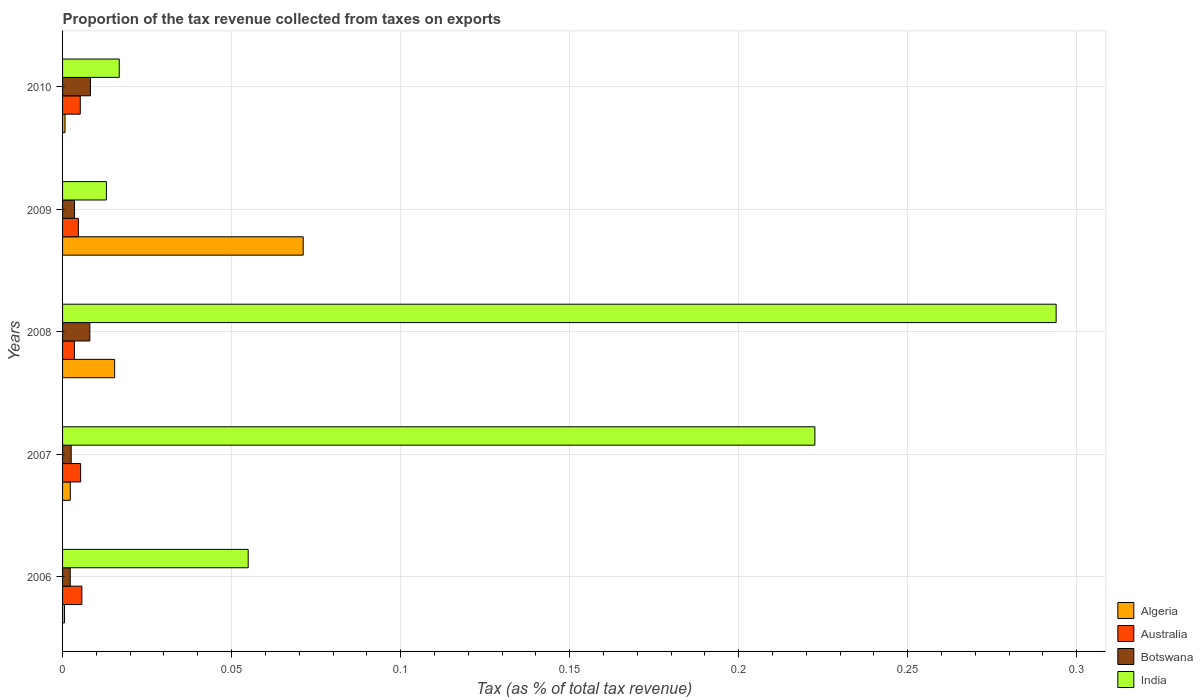How many different coloured bars are there?
Keep it short and to the point. 4. Are the number of bars per tick equal to the number of legend labels?
Provide a short and direct response. Yes. Are the number of bars on each tick of the Y-axis equal?
Your answer should be very brief. Yes. How many bars are there on the 1st tick from the bottom?
Make the answer very short. 4. What is the label of the 4th group of bars from the top?
Provide a short and direct response. 2007. In how many cases, is the number of bars for a given year not equal to the number of legend labels?
Offer a very short reply. 0. What is the proportion of the tax revenue collected in Australia in 2006?
Provide a short and direct response. 0.01. Across all years, what is the maximum proportion of the tax revenue collected in Botswana?
Your answer should be very brief. 0.01. Across all years, what is the minimum proportion of the tax revenue collected in India?
Keep it short and to the point. 0.01. In which year was the proportion of the tax revenue collected in Algeria minimum?
Make the answer very short. 2006. What is the total proportion of the tax revenue collected in India in the graph?
Ensure brevity in your answer.  0.6. What is the difference between the proportion of the tax revenue collected in Australia in 2007 and that in 2010?
Keep it short and to the point. 0. What is the difference between the proportion of the tax revenue collected in India in 2010 and the proportion of the tax revenue collected in Australia in 2008?
Make the answer very short. 0.01. What is the average proportion of the tax revenue collected in Australia per year?
Provide a succinct answer. 0. In the year 2010, what is the difference between the proportion of the tax revenue collected in Botswana and proportion of the tax revenue collected in Australia?
Keep it short and to the point. 0. What is the ratio of the proportion of the tax revenue collected in India in 2006 to that in 2010?
Your answer should be compact. 3.27. Is the difference between the proportion of the tax revenue collected in Botswana in 2007 and 2010 greater than the difference between the proportion of the tax revenue collected in Australia in 2007 and 2010?
Ensure brevity in your answer.  No. What is the difference between the highest and the second highest proportion of the tax revenue collected in Algeria?
Your answer should be very brief. 0.06. What is the difference between the highest and the lowest proportion of the tax revenue collected in Botswana?
Give a very brief answer. 0.01. Is the sum of the proportion of the tax revenue collected in Australia in 2006 and 2009 greater than the maximum proportion of the tax revenue collected in India across all years?
Give a very brief answer. No. What does the 4th bar from the top in 2008 represents?
Keep it short and to the point. Algeria. What does the 2nd bar from the bottom in 2007 represents?
Offer a very short reply. Australia. Is it the case that in every year, the sum of the proportion of the tax revenue collected in India and proportion of the tax revenue collected in Algeria is greater than the proportion of the tax revenue collected in Australia?
Offer a very short reply. Yes. How many legend labels are there?
Your response must be concise. 4. What is the title of the graph?
Your answer should be very brief. Proportion of the tax revenue collected from taxes on exports. Does "Dominica" appear as one of the legend labels in the graph?
Give a very brief answer. No. What is the label or title of the X-axis?
Offer a very short reply. Tax (as % of total tax revenue). What is the label or title of the Y-axis?
Offer a terse response. Years. What is the Tax (as % of total tax revenue) in Algeria in 2006?
Your answer should be very brief. 0. What is the Tax (as % of total tax revenue) of Australia in 2006?
Provide a succinct answer. 0.01. What is the Tax (as % of total tax revenue) of Botswana in 2006?
Make the answer very short. 0. What is the Tax (as % of total tax revenue) in India in 2006?
Give a very brief answer. 0.05. What is the Tax (as % of total tax revenue) of Algeria in 2007?
Provide a succinct answer. 0. What is the Tax (as % of total tax revenue) in Australia in 2007?
Make the answer very short. 0.01. What is the Tax (as % of total tax revenue) of Botswana in 2007?
Give a very brief answer. 0. What is the Tax (as % of total tax revenue) in India in 2007?
Make the answer very short. 0.22. What is the Tax (as % of total tax revenue) in Algeria in 2008?
Ensure brevity in your answer.  0.02. What is the Tax (as % of total tax revenue) of Australia in 2008?
Your answer should be compact. 0. What is the Tax (as % of total tax revenue) in Botswana in 2008?
Make the answer very short. 0.01. What is the Tax (as % of total tax revenue) in India in 2008?
Offer a terse response. 0.29. What is the Tax (as % of total tax revenue) in Algeria in 2009?
Offer a very short reply. 0.07. What is the Tax (as % of total tax revenue) in Australia in 2009?
Make the answer very short. 0. What is the Tax (as % of total tax revenue) in Botswana in 2009?
Give a very brief answer. 0. What is the Tax (as % of total tax revenue) in India in 2009?
Your answer should be very brief. 0.01. What is the Tax (as % of total tax revenue) in Algeria in 2010?
Keep it short and to the point. 0. What is the Tax (as % of total tax revenue) in Australia in 2010?
Offer a very short reply. 0.01. What is the Tax (as % of total tax revenue) of Botswana in 2010?
Your answer should be compact. 0.01. What is the Tax (as % of total tax revenue) of India in 2010?
Keep it short and to the point. 0.02. Across all years, what is the maximum Tax (as % of total tax revenue) of Algeria?
Your answer should be very brief. 0.07. Across all years, what is the maximum Tax (as % of total tax revenue) in Australia?
Ensure brevity in your answer.  0.01. Across all years, what is the maximum Tax (as % of total tax revenue) in Botswana?
Your response must be concise. 0.01. Across all years, what is the maximum Tax (as % of total tax revenue) of India?
Your answer should be compact. 0.29. Across all years, what is the minimum Tax (as % of total tax revenue) in Algeria?
Ensure brevity in your answer.  0. Across all years, what is the minimum Tax (as % of total tax revenue) of Australia?
Your response must be concise. 0. Across all years, what is the minimum Tax (as % of total tax revenue) of Botswana?
Ensure brevity in your answer.  0. Across all years, what is the minimum Tax (as % of total tax revenue) in India?
Your response must be concise. 0.01. What is the total Tax (as % of total tax revenue) of Algeria in the graph?
Offer a very short reply. 0.09. What is the total Tax (as % of total tax revenue) in Australia in the graph?
Provide a succinct answer. 0.02. What is the total Tax (as % of total tax revenue) in Botswana in the graph?
Provide a short and direct response. 0.02. What is the total Tax (as % of total tax revenue) of India in the graph?
Make the answer very short. 0.6. What is the difference between the Tax (as % of total tax revenue) of Algeria in 2006 and that in 2007?
Provide a short and direct response. -0. What is the difference between the Tax (as % of total tax revenue) of Botswana in 2006 and that in 2007?
Ensure brevity in your answer.  -0. What is the difference between the Tax (as % of total tax revenue) of India in 2006 and that in 2007?
Your answer should be very brief. -0.17. What is the difference between the Tax (as % of total tax revenue) of Algeria in 2006 and that in 2008?
Give a very brief answer. -0.01. What is the difference between the Tax (as % of total tax revenue) in Australia in 2006 and that in 2008?
Provide a succinct answer. 0. What is the difference between the Tax (as % of total tax revenue) of Botswana in 2006 and that in 2008?
Ensure brevity in your answer.  -0.01. What is the difference between the Tax (as % of total tax revenue) of India in 2006 and that in 2008?
Make the answer very short. -0.24. What is the difference between the Tax (as % of total tax revenue) in Algeria in 2006 and that in 2009?
Give a very brief answer. -0.07. What is the difference between the Tax (as % of total tax revenue) in Botswana in 2006 and that in 2009?
Your answer should be compact. -0. What is the difference between the Tax (as % of total tax revenue) of India in 2006 and that in 2009?
Your answer should be compact. 0.04. What is the difference between the Tax (as % of total tax revenue) of Algeria in 2006 and that in 2010?
Your answer should be compact. -0. What is the difference between the Tax (as % of total tax revenue) in Botswana in 2006 and that in 2010?
Make the answer very short. -0.01. What is the difference between the Tax (as % of total tax revenue) in India in 2006 and that in 2010?
Give a very brief answer. 0.04. What is the difference between the Tax (as % of total tax revenue) of Algeria in 2007 and that in 2008?
Your answer should be compact. -0.01. What is the difference between the Tax (as % of total tax revenue) of Australia in 2007 and that in 2008?
Your response must be concise. 0. What is the difference between the Tax (as % of total tax revenue) of Botswana in 2007 and that in 2008?
Give a very brief answer. -0.01. What is the difference between the Tax (as % of total tax revenue) in India in 2007 and that in 2008?
Keep it short and to the point. -0.07. What is the difference between the Tax (as % of total tax revenue) in Algeria in 2007 and that in 2009?
Offer a very short reply. -0.07. What is the difference between the Tax (as % of total tax revenue) of Australia in 2007 and that in 2009?
Your answer should be very brief. 0. What is the difference between the Tax (as % of total tax revenue) of Botswana in 2007 and that in 2009?
Provide a short and direct response. -0. What is the difference between the Tax (as % of total tax revenue) of India in 2007 and that in 2009?
Offer a very short reply. 0.21. What is the difference between the Tax (as % of total tax revenue) of Algeria in 2007 and that in 2010?
Your answer should be compact. 0. What is the difference between the Tax (as % of total tax revenue) in Botswana in 2007 and that in 2010?
Your answer should be very brief. -0.01. What is the difference between the Tax (as % of total tax revenue) in India in 2007 and that in 2010?
Your answer should be very brief. 0.21. What is the difference between the Tax (as % of total tax revenue) of Algeria in 2008 and that in 2009?
Keep it short and to the point. -0.06. What is the difference between the Tax (as % of total tax revenue) of Australia in 2008 and that in 2009?
Your answer should be compact. -0. What is the difference between the Tax (as % of total tax revenue) in Botswana in 2008 and that in 2009?
Offer a terse response. 0. What is the difference between the Tax (as % of total tax revenue) in India in 2008 and that in 2009?
Ensure brevity in your answer.  0.28. What is the difference between the Tax (as % of total tax revenue) in Algeria in 2008 and that in 2010?
Your answer should be very brief. 0.01. What is the difference between the Tax (as % of total tax revenue) in Australia in 2008 and that in 2010?
Keep it short and to the point. -0. What is the difference between the Tax (as % of total tax revenue) in Botswana in 2008 and that in 2010?
Provide a succinct answer. -0. What is the difference between the Tax (as % of total tax revenue) in India in 2008 and that in 2010?
Provide a short and direct response. 0.28. What is the difference between the Tax (as % of total tax revenue) of Algeria in 2009 and that in 2010?
Keep it short and to the point. 0.07. What is the difference between the Tax (as % of total tax revenue) in Australia in 2009 and that in 2010?
Your answer should be compact. -0. What is the difference between the Tax (as % of total tax revenue) of Botswana in 2009 and that in 2010?
Offer a terse response. -0. What is the difference between the Tax (as % of total tax revenue) of India in 2009 and that in 2010?
Your answer should be very brief. -0. What is the difference between the Tax (as % of total tax revenue) of Algeria in 2006 and the Tax (as % of total tax revenue) of Australia in 2007?
Your answer should be very brief. -0. What is the difference between the Tax (as % of total tax revenue) in Algeria in 2006 and the Tax (as % of total tax revenue) in Botswana in 2007?
Your response must be concise. -0. What is the difference between the Tax (as % of total tax revenue) of Algeria in 2006 and the Tax (as % of total tax revenue) of India in 2007?
Give a very brief answer. -0.22. What is the difference between the Tax (as % of total tax revenue) of Australia in 2006 and the Tax (as % of total tax revenue) of Botswana in 2007?
Your response must be concise. 0. What is the difference between the Tax (as % of total tax revenue) in Australia in 2006 and the Tax (as % of total tax revenue) in India in 2007?
Keep it short and to the point. -0.22. What is the difference between the Tax (as % of total tax revenue) in Botswana in 2006 and the Tax (as % of total tax revenue) in India in 2007?
Provide a short and direct response. -0.22. What is the difference between the Tax (as % of total tax revenue) in Algeria in 2006 and the Tax (as % of total tax revenue) in Australia in 2008?
Provide a short and direct response. -0. What is the difference between the Tax (as % of total tax revenue) in Algeria in 2006 and the Tax (as % of total tax revenue) in Botswana in 2008?
Your answer should be very brief. -0.01. What is the difference between the Tax (as % of total tax revenue) in Algeria in 2006 and the Tax (as % of total tax revenue) in India in 2008?
Keep it short and to the point. -0.29. What is the difference between the Tax (as % of total tax revenue) of Australia in 2006 and the Tax (as % of total tax revenue) of Botswana in 2008?
Provide a succinct answer. -0. What is the difference between the Tax (as % of total tax revenue) of Australia in 2006 and the Tax (as % of total tax revenue) of India in 2008?
Offer a very short reply. -0.29. What is the difference between the Tax (as % of total tax revenue) of Botswana in 2006 and the Tax (as % of total tax revenue) of India in 2008?
Keep it short and to the point. -0.29. What is the difference between the Tax (as % of total tax revenue) in Algeria in 2006 and the Tax (as % of total tax revenue) in Australia in 2009?
Offer a very short reply. -0. What is the difference between the Tax (as % of total tax revenue) in Algeria in 2006 and the Tax (as % of total tax revenue) in Botswana in 2009?
Ensure brevity in your answer.  -0. What is the difference between the Tax (as % of total tax revenue) in Algeria in 2006 and the Tax (as % of total tax revenue) in India in 2009?
Give a very brief answer. -0.01. What is the difference between the Tax (as % of total tax revenue) in Australia in 2006 and the Tax (as % of total tax revenue) in Botswana in 2009?
Your answer should be very brief. 0. What is the difference between the Tax (as % of total tax revenue) of Australia in 2006 and the Tax (as % of total tax revenue) of India in 2009?
Ensure brevity in your answer.  -0.01. What is the difference between the Tax (as % of total tax revenue) of Botswana in 2006 and the Tax (as % of total tax revenue) of India in 2009?
Keep it short and to the point. -0.01. What is the difference between the Tax (as % of total tax revenue) in Algeria in 2006 and the Tax (as % of total tax revenue) in Australia in 2010?
Your answer should be compact. -0. What is the difference between the Tax (as % of total tax revenue) of Algeria in 2006 and the Tax (as % of total tax revenue) of Botswana in 2010?
Your response must be concise. -0.01. What is the difference between the Tax (as % of total tax revenue) in Algeria in 2006 and the Tax (as % of total tax revenue) in India in 2010?
Provide a short and direct response. -0.02. What is the difference between the Tax (as % of total tax revenue) of Australia in 2006 and the Tax (as % of total tax revenue) of Botswana in 2010?
Offer a very short reply. -0. What is the difference between the Tax (as % of total tax revenue) in Australia in 2006 and the Tax (as % of total tax revenue) in India in 2010?
Ensure brevity in your answer.  -0.01. What is the difference between the Tax (as % of total tax revenue) of Botswana in 2006 and the Tax (as % of total tax revenue) of India in 2010?
Provide a succinct answer. -0.01. What is the difference between the Tax (as % of total tax revenue) in Algeria in 2007 and the Tax (as % of total tax revenue) in Australia in 2008?
Ensure brevity in your answer.  -0. What is the difference between the Tax (as % of total tax revenue) of Algeria in 2007 and the Tax (as % of total tax revenue) of Botswana in 2008?
Ensure brevity in your answer.  -0.01. What is the difference between the Tax (as % of total tax revenue) of Algeria in 2007 and the Tax (as % of total tax revenue) of India in 2008?
Your answer should be compact. -0.29. What is the difference between the Tax (as % of total tax revenue) in Australia in 2007 and the Tax (as % of total tax revenue) in Botswana in 2008?
Provide a short and direct response. -0. What is the difference between the Tax (as % of total tax revenue) of Australia in 2007 and the Tax (as % of total tax revenue) of India in 2008?
Offer a terse response. -0.29. What is the difference between the Tax (as % of total tax revenue) of Botswana in 2007 and the Tax (as % of total tax revenue) of India in 2008?
Your answer should be compact. -0.29. What is the difference between the Tax (as % of total tax revenue) in Algeria in 2007 and the Tax (as % of total tax revenue) in Australia in 2009?
Your response must be concise. -0. What is the difference between the Tax (as % of total tax revenue) in Algeria in 2007 and the Tax (as % of total tax revenue) in Botswana in 2009?
Ensure brevity in your answer.  -0. What is the difference between the Tax (as % of total tax revenue) of Algeria in 2007 and the Tax (as % of total tax revenue) of India in 2009?
Provide a succinct answer. -0.01. What is the difference between the Tax (as % of total tax revenue) of Australia in 2007 and the Tax (as % of total tax revenue) of Botswana in 2009?
Your answer should be compact. 0. What is the difference between the Tax (as % of total tax revenue) of Australia in 2007 and the Tax (as % of total tax revenue) of India in 2009?
Your answer should be very brief. -0.01. What is the difference between the Tax (as % of total tax revenue) of Botswana in 2007 and the Tax (as % of total tax revenue) of India in 2009?
Provide a succinct answer. -0.01. What is the difference between the Tax (as % of total tax revenue) in Algeria in 2007 and the Tax (as % of total tax revenue) in Australia in 2010?
Ensure brevity in your answer.  -0. What is the difference between the Tax (as % of total tax revenue) of Algeria in 2007 and the Tax (as % of total tax revenue) of Botswana in 2010?
Your answer should be compact. -0.01. What is the difference between the Tax (as % of total tax revenue) of Algeria in 2007 and the Tax (as % of total tax revenue) of India in 2010?
Make the answer very short. -0.01. What is the difference between the Tax (as % of total tax revenue) in Australia in 2007 and the Tax (as % of total tax revenue) in Botswana in 2010?
Give a very brief answer. -0. What is the difference between the Tax (as % of total tax revenue) of Australia in 2007 and the Tax (as % of total tax revenue) of India in 2010?
Your response must be concise. -0.01. What is the difference between the Tax (as % of total tax revenue) in Botswana in 2007 and the Tax (as % of total tax revenue) in India in 2010?
Provide a succinct answer. -0.01. What is the difference between the Tax (as % of total tax revenue) of Algeria in 2008 and the Tax (as % of total tax revenue) of Australia in 2009?
Keep it short and to the point. 0.01. What is the difference between the Tax (as % of total tax revenue) of Algeria in 2008 and the Tax (as % of total tax revenue) of Botswana in 2009?
Make the answer very short. 0.01. What is the difference between the Tax (as % of total tax revenue) of Algeria in 2008 and the Tax (as % of total tax revenue) of India in 2009?
Ensure brevity in your answer.  0. What is the difference between the Tax (as % of total tax revenue) in Australia in 2008 and the Tax (as % of total tax revenue) in Botswana in 2009?
Provide a succinct answer. -0. What is the difference between the Tax (as % of total tax revenue) of Australia in 2008 and the Tax (as % of total tax revenue) of India in 2009?
Give a very brief answer. -0.01. What is the difference between the Tax (as % of total tax revenue) in Botswana in 2008 and the Tax (as % of total tax revenue) in India in 2009?
Your answer should be compact. -0. What is the difference between the Tax (as % of total tax revenue) in Algeria in 2008 and the Tax (as % of total tax revenue) in Australia in 2010?
Offer a terse response. 0.01. What is the difference between the Tax (as % of total tax revenue) of Algeria in 2008 and the Tax (as % of total tax revenue) of Botswana in 2010?
Keep it short and to the point. 0.01. What is the difference between the Tax (as % of total tax revenue) in Algeria in 2008 and the Tax (as % of total tax revenue) in India in 2010?
Keep it short and to the point. -0. What is the difference between the Tax (as % of total tax revenue) in Australia in 2008 and the Tax (as % of total tax revenue) in Botswana in 2010?
Ensure brevity in your answer.  -0. What is the difference between the Tax (as % of total tax revenue) in Australia in 2008 and the Tax (as % of total tax revenue) in India in 2010?
Give a very brief answer. -0.01. What is the difference between the Tax (as % of total tax revenue) in Botswana in 2008 and the Tax (as % of total tax revenue) in India in 2010?
Your answer should be compact. -0.01. What is the difference between the Tax (as % of total tax revenue) in Algeria in 2009 and the Tax (as % of total tax revenue) in Australia in 2010?
Offer a terse response. 0.07. What is the difference between the Tax (as % of total tax revenue) of Algeria in 2009 and the Tax (as % of total tax revenue) of Botswana in 2010?
Ensure brevity in your answer.  0.06. What is the difference between the Tax (as % of total tax revenue) in Algeria in 2009 and the Tax (as % of total tax revenue) in India in 2010?
Give a very brief answer. 0.05. What is the difference between the Tax (as % of total tax revenue) in Australia in 2009 and the Tax (as % of total tax revenue) in Botswana in 2010?
Offer a terse response. -0. What is the difference between the Tax (as % of total tax revenue) in Australia in 2009 and the Tax (as % of total tax revenue) in India in 2010?
Your response must be concise. -0.01. What is the difference between the Tax (as % of total tax revenue) in Botswana in 2009 and the Tax (as % of total tax revenue) in India in 2010?
Make the answer very short. -0.01. What is the average Tax (as % of total tax revenue) in Algeria per year?
Offer a terse response. 0.02. What is the average Tax (as % of total tax revenue) of Australia per year?
Keep it short and to the point. 0. What is the average Tax (as % of total tax revenue) of Botswana per year?
Provide a short and direct response. 0. What is the average Tax (as % of total tax revenue) in India per year?
Make the answer very short. 0.12. In the year 2006, what is the difference between the Tax (as % of total tax revenue) in Algeria and Tax (as % of total tax revenue) in Australia?
Keep it short and to the point. -0.01. In the year 2006, what is the difference between the Tax (as % of total tax revenue) of Algeria and Tax (as % of total tax revenue) of Botswana?
Make the answer very short. -0. In the year 2006, what is the difference between the Tax (as % of total tax revenue) in Algeria and Tax (as % of total tax revenue) in India?
Provide a short and direct response. -0.05. In the year 2006, what is the difference between the Tax (as % of total tax revenue) in Australia and Tax (as % of total tax revenue) in Botswana?
Provide a short and direct response. 0. In the year 2006, what is the difference between the Tax (as % of total tax revenue) of Australia and Tax (as % of total tax revenue) of India?
Keep it short and to the point. -0.05. In the year 2006, what is the difference between the Tax (as % of total tax revenue) in Botswana and Tax (as % of total tax revenue) in India?
Provide a short and direct response. -0.05. In the year 2007, what is the difference between the Tax (as % of total tax revenue) in Algeria and Tax (as % of total tax revenue) in Australia?
Make the answer very short. -0. In the year 2007, what is the difference between the Tax (as % of total tax revenue) of Algeria and Tax (as % of total tax revenue) of Botswana?
Ensure brevity in your answer.  -0. In the year 2007, what is the difference between the Tax (as % of total tax revenue) in Algeria and Tax (as % of total tax revenue) in India?
Your response must be concise. -0.22. In the year 2007, what is the difference between the Tax (as % of total tax revenue) of Australia and Tax (as % of total tax revenue) of Botswana?
Your response must be concise. 0. In the year 2007, what is the difference between the Tax (as % of total tax revenue) in Australia and Tax (as % of total tax revenue) in India?
Offer a very short reply. -0.22. In the year 2007, what is the difference between the Tax (as % of total tax revenue) in Botswana and Tax (as % of total tax revenue) in India?
Make the answer very short. -0.22. In the year 2008, what is the difference between the Tax (as % of total tax revenue) in Algeria and Tax (as % of total tax revenue) in Australia?
Provide a short and direct response. 0.01. In the year 2008, what is the difference between the Tax (as % of total tax revenue) of Algeria and Tax (as % of total tax revenue) of Botswana?
Your response must be concise. 0.01. In the year 2008, what is the difference between the Tax (as % of total tax revenue) in Algeria and Tax (as % of total tax revenue) in India?
Keep it short and to the point. -0.28. In the year 2008, what is the difference between the Tax (as % of total tax revenue) in Australia and Tax (as % of total tax revenue) in Botswana?
Your response must be concise. -0. In the year 2008, what is the difference between the Tax (as % of total tax revenue) of Australia and Tax (as % of total tax revenue) of India?
Your answer should be compact. -0.29. In the year 2008, what is the difference between the Tax (as % of total tax revenue) in Botswana and Tax (as % of total tax revenue) in India?
Provide a succinct answer. -0.29. In the year 2009, what is the difference between the Tax (as % of total tax revenue) of Algeria and Tax (as % of total tax revenue) of Australia?
Give a very brief answer. 0.07. In the year 2009, what is the difference between the Tax (as % of total tax revenue) of Algeria and Tax (as % of total tax revenue) of Botswana?
Offer a terse response. 0.07. In the year 2009, what is the difference between the Tax (as % of total tax revenue) in Algeria and Tax (as % of total tax revenue) in India?
Provide a short and direct response. 0.06. In the year 2009, what is the difference between the Tax (as % of total tax revenue) in Australia and Tax (as % of total tax revenue) in Botswana?
Make the answer very short. 0. In the year 2009, what is the difference between the Tax (as % of total tax revenue) of Australia and Tax (as % of total tax revenue) of India?
Your answer should be compact. -0.01. In the year 2009, what is the difference between the Tax (as % of total tax revenue) of Botswana and Tax (as % of total tax revenue) of India?
Make the answer very short. -0.01. In the year 2010, what is the difference between the Tax (as % of total tax revenue) in Algeria and Tax (as % of total tax revenue) in Australia?
Your answer should be very brief. -0. In the year 2010, what is the difference between the Tax (as % of total tax revenue) in Algeria and Tax (as % of total tax revenue) in Botswana?
Provide a succinct answer. -0.01. In the year 2010, what is the difference between the Tax (as % of total tax revenue) of Algeria and Tax (as % of total tax revenue) of India?
Offer a terse response. -0.02. In the year 2010, what is the difference between the Tax (as % of total tax revenue) of Australia and Tax (as % of total tax revenue) of Botswana?
Make the answer very short. -0. In the year 2010, what is the difference between the Tax (as % of total tax revenue) in Australia and Tax (as % of total tax revenue) in India?
Make the answer very short. -0.01. In the year 2010, what is the difference between the Tax (as % of total tax revenue) of Botswana and Tax (as % of total tax revenue) of India?
Ensure brevity in your answer.  -0.01. What is the ratio of the Tax (as % of total tax revenue) in Algeria in 2006 to that in 2007?
Your answer should be very brief. 0.25. What is the ratio of the Tax (as % of total tax revenue) in Australia in 2006 to that in 2007?
Ensure brevity in your answer.  1.07. What is the ratio of the Tax (as % of total tax revenue) in Botswana in 2006 to that in 2007?
Make the answer very short. 0.89. What is the ratio of the Tax (as % of total tax revenue) of India in 2006 to that in 2007?
Provide a succinct answer. 0.25. What is the ratio of the Tax (as % of total tax revenue) in Algeria in 2006 to that in 2008?
Make the answer very short. 0.04. What is the ratio of the Tax (as % of total tax revenue) of Australia in 2006 to that in 2008?
Ensure brevity in your answer.  1.63. What is the ratio of the Tax (as % of total tax revenue) of Botswana in 2006 to that in 2008?
Provide a succinct answer. 0.28. What is the ratio of the Tax (as % of total tax revenue) in India in 2006 to that in 2008?
Offer a terse response. 0.19. What is the ratio of the Tax (as % of total tax revenue) in Algeria in 2006 to that in 2009?
Provide a short and direct response. 0.01. What is the ratio of the Tax (as % of total tax revenue) of Australia in 2006 to that in 2009?
Your answer should be very brief. 1.22. What is the ratio of the Tax (as % of total tax revenue) of Botswana in 2006 to that in 2009?
Your answer should be compact. 0.64. What is the ratio of the Tax (as % of total tax revenue) in India in 2006 to that in 2009?
Offer a terse response. 4.23. What is the ratio of the Tax (as % of total tax revenue) of Algeria in 2006 to that in 2010?
Give a very brief answer. 0.79. What is the ratio of the Tax (as % of total tax revenue) of Australia in 2006 to that in 2010?
Give a very brief answer. 1.09. What is the ratio of the Tax (as % of total tax revenue) in Botswana in 2006 to that in 2010?
Make the answer very short. 0.27. What is the ratio of the Tax (as % of total tax revenue) of India in 2006 to that in 2010?
Give a very brief answer. 3.27. What is the ratio of the Tax (as % of total tax revenue) in Algeria in 2007 to that in 2008?
Your response must be concise. 0.15. What is the ratio of the Tax (as % of total tax revenue) in Australia in 2007 to that in 2008?
Provide a succinct answer. 1.53. What is the ratio of the Tax (as % of total tax revenue) of Botswana in 2007 to that in 2008?
Offer a terse response. 0.32. What is the ratio of the Tax (as % of total tax revenue) in India in 2007 to that in 2008?
Keep it short and to the point. 0.76. What is the ratio of the Tax (as % of total tax revenue) of Algeria in 2007 to that in 2009?
Give a very brief answer. 0.03. What is the ratio of the Tax (as % of total tax revenue) of Australia in 2007 to that in 2009?
Offer a very short reply. 1.14. What is the ratio of the Tax (as % of total tax revenue) of Botswana in 2007 to that in 2009?
Make the answer very short. 0.72. What is the ratio of the Tax (as % of total tax revenue) of India in 2007 to that in 2009?
Give a very brief answer. 17.16. What is the ratio of the Tax (as % of total tax revenue) of Algeria in 2007 to that in 2010?
Your answer should be compact. 3.14. What is the ratio of the Tax (as % of total tax revenue) of Australia in 2007 to that in 2010?
Your answer should be very brief. 1.02. What is the ratio of the Tax (as % of total tax revenue) of Botswana in 2007 to that in 2010?
Make the answer very short. 0.31. What is the ratio of the Tax (as % of total tax revenue) in India in 2007 to that in 2010?
Make the answer very short. 13.27. What is the ratio of the Tax (as % of total tax revenue) in Algeria in 2008 to that in 2009?
Offer a terse response. 0.22. What is the ratio of the Tax (as % of total tax revenue) in Australia in 2008 to that in 2009?
Ensure brevity in your answer.  0.75. What is the ratio of the Tax (as % of total tax revenue) of Botswana in 2008 to that in 2009?
Offer a very short reply. 2.28. What is the ratio of the Tax (as % of total tax revenue) of India in 2008 to that in 2009?
Provide a short and direct response. 22.66. What is the ratio of the Tax (as % of total tax revenue) in Algeria in 2008 to that in 2010?
Offer a very short reply. 21.19. What is the ratio of the Tax (as % of total tax revenue) in Australia in 2008 to that in 2010?
Your answer should be very brief. 0.67. What is the ratio of the Tax (as % of total tax revenue) in Botswana in 2008 to that in 2010?
Ensure brevity in your answer.  0.98. What is the ratio of the Tax (as % of total tax revenue) in India in 2008 to that in 2010?
Offer a very short reply. 17.53. What is the ratio of the Tax (as % of total tax revenue) in Algeria in 2009 to that in 2010?
Your response must be concise. 97.89. What is the ratio of the Tax (as % of total tax revenue) of Australia in 2009 to that in 2010?
Offer a terse response. 0.89. What is the ratio of the Tax (as % of total tax revenue) of Botswana in 2009 to that in 2010?
Provide a succinct answer. 0.43. What is the ratio of the Tax (as % of total tax revenue) of India in 2009 to that in 2010?
Your answer should be very brief. 0.77. What is the difference between the highest and the second highest Tax (as % of total tax revenue) of Algeria?
Your answer should be very brief. 0.06. What is the difference between the highest and the second highest Tax (as % of total tax revenue) of Australia?
Make the answer very short. 0. What is the difference between the highest and the second highest Tax (as % of total tax revenue) of Botswana?
Offer a very short reply. 0. What is the difference between the highest and the second highest Tax (as % of total tax revenue) in India?
Give a very brief answer. 0.07. What is the difference between the highest and the lowest Tax (as % of total tax revenue) of Algeria?
Give a very brief answer. 0.07. What is the difference between the highest and the lowest Tax (as % of total tax revenue) in Australia?
Make the answer very short. 0. What is the difference between the highest and the lowest Tax (as % of total tax revenue) in Botswana?
Offer a terse response. 0.01. What is the difference between the highest and the lowest Tax (as % of total tax revenue) in India?
Make the answer very short. 0.28. 